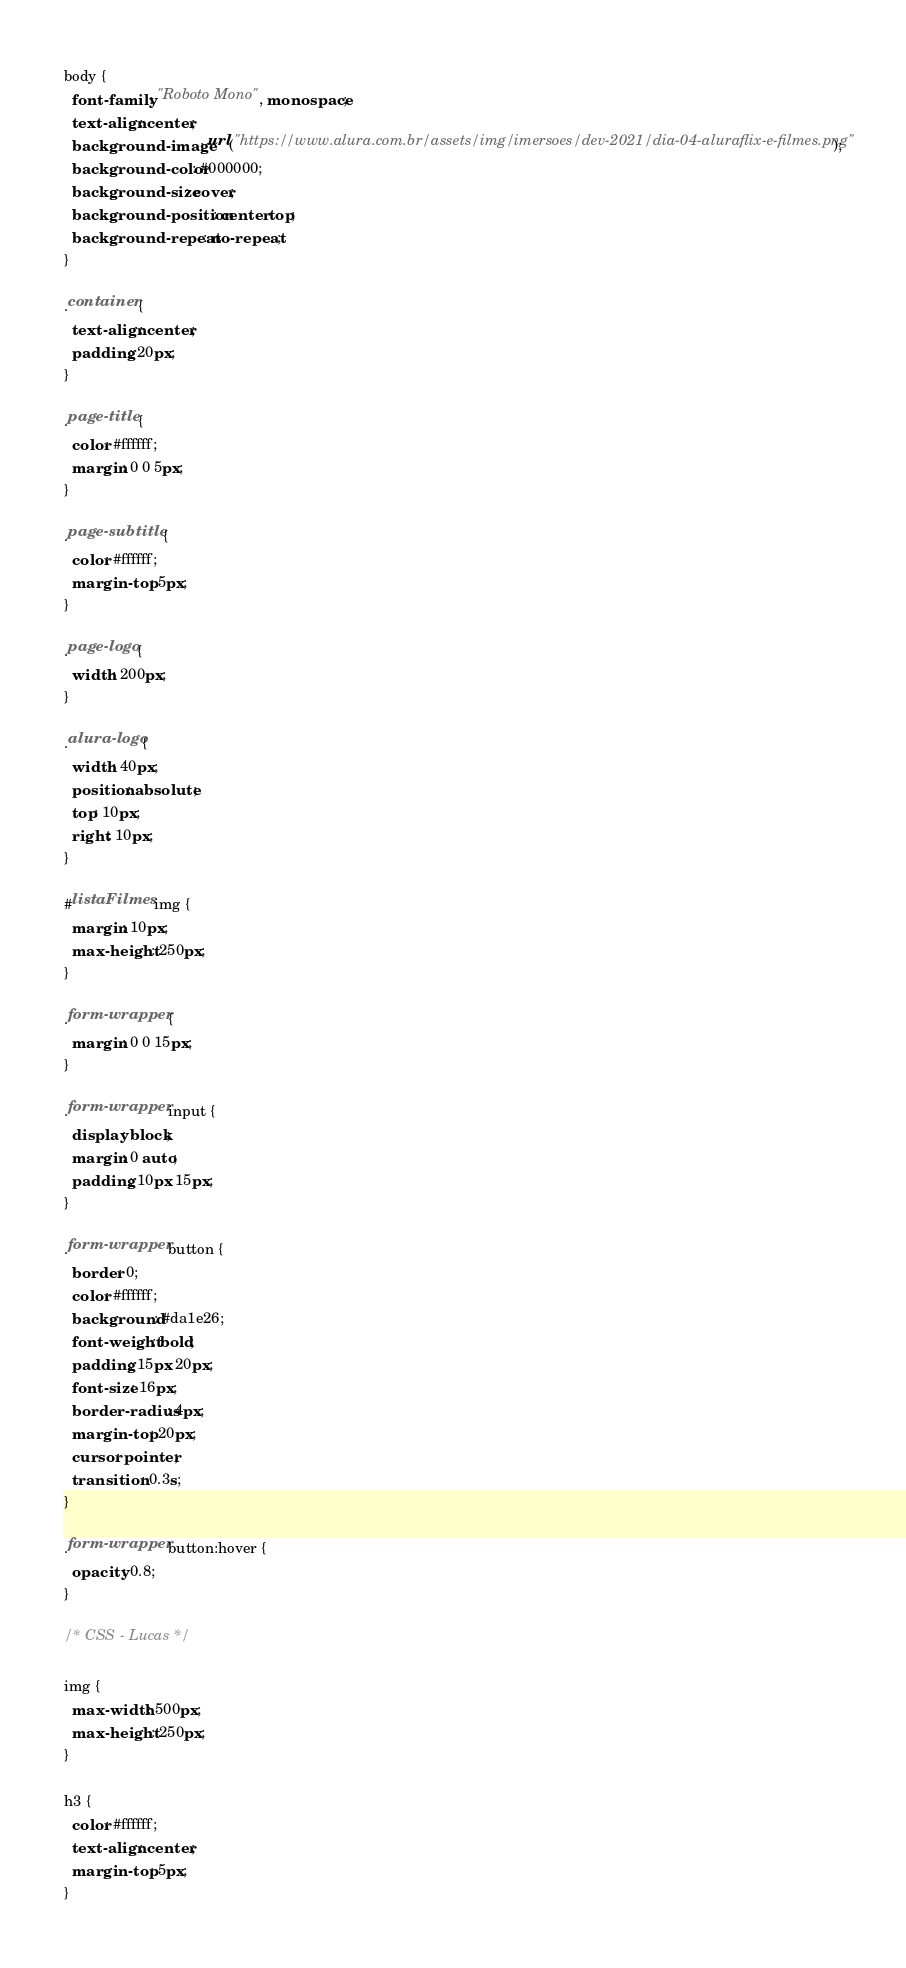Convert code to text. <code><loc_0><loc_0><loc_500><loc_500><_CSS_>body {
  font-family: "Roboto Mono", monospace;
  text-align: center;
  background-image: url("https://www.alura.com.br/assets/img/imersoes/dev-2021/dia-04-aluraflix-e-filmes.png");
  background-color: #000000;
  background-size: cover;
  background-position: center top;
  background-repeat: no-repeat;
}

.container {
  text-align: center;
  padding: 20px;
}

.page-title {
  color: #ffffff;
  margin: 0 0 5px;
}

.page-subtitle {
  color: #ffffff;
  margin-top: 5px;
}

.page-logo {
  width: 200px;
}

.alura-logo {
  width: 40px;
  position: absolute;
  top: 10px;
  right: 10px;
}

#listaFilmes img {
  margin: 10px;
  max-height: 250px;
}

.form-wrapper {
  margin: 0 0 15px;
}

.form-wrapper input {
  display: block;
  margin: 0 auto;
  padding: 10px 15px;
}

.form-wrapper button {
  border: 0;
  color: #ffffff;
  background: #da1e26;
  font-weight: bold;
  padding: 15px 20px;
  font-size: 16px;
  border-radius: 4px;
  margin-top: 20px;
  cursor: pointer;
  transition: 0.3s;
}

.form-wrapper button:hover {
  opacity: 0.8;
}

/* CSS - Lucas */

img {
  max-width: 500px;
  max-height: 250px;
}

h3 {
  color: #ffffff;
  text-align: center;
  margin-top: 5px;
}</code> 